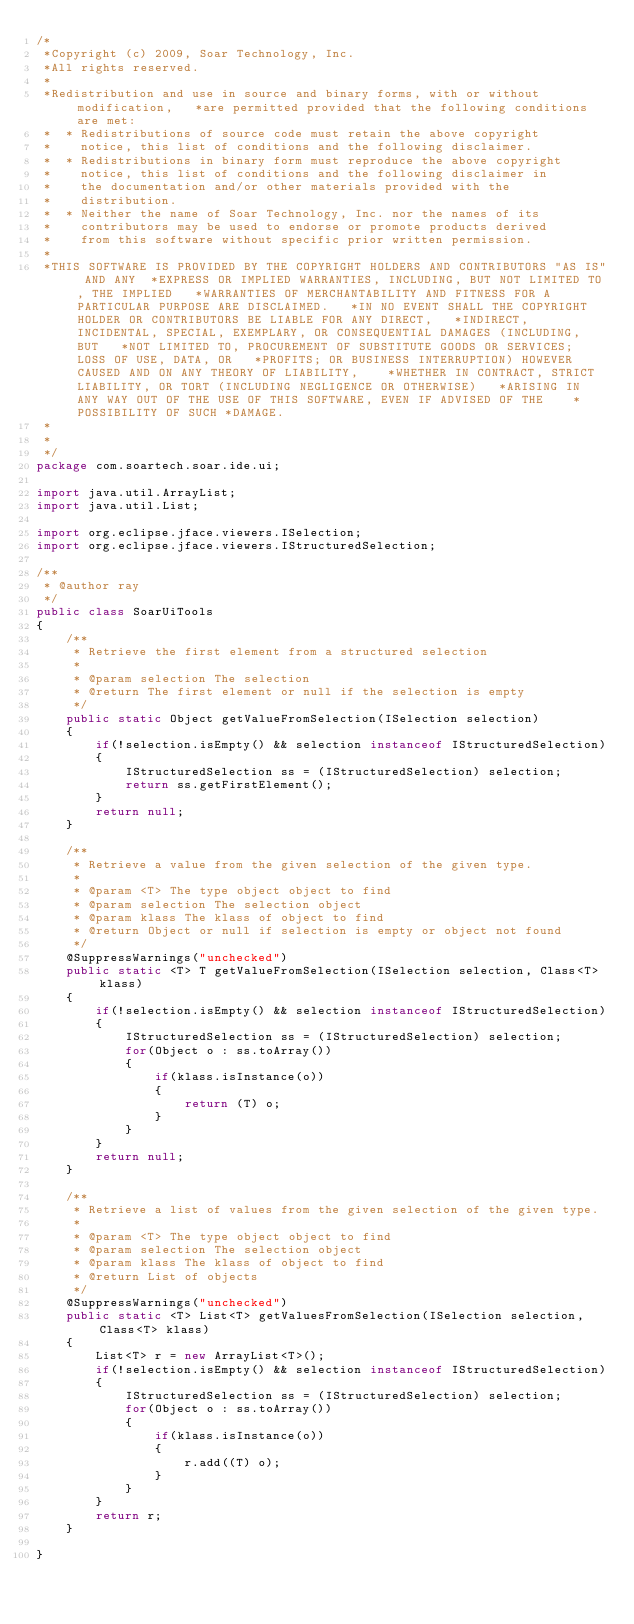<code> <loc_0><loc_0><loc_500><loc_500><_Java_>/*
 *Copyright (c) 2009, Soar Technology, Inc.
 *All rights reserved.
 *
 *Redistribution and use in source and binary forms, with or without modification,   *are permitted provided that the following conditions are met:
 *  * Redistributions of source code must retain the above copyright
 *    notice, this list of conditions and the following disclaimer.
 *  * Redistributions in binary form must reproduce the above copyright
 *    notice, this list of conditions and the following disclaimer in
 *    the documentation and/or other materials provided with the
 *    distribution.
 *  * Neither the name of Soar Technology, Inc. nor the names of its
 *    contributors may be used to endorse or promote products derived
 *    from this software without specific prior written permission.
 *
 *THIS SOFTWARE IS PROVIDED BY THE COPYRIGHT HOLDERS AND CONTRIBUTORS "AS IS" AND ANY  *EXPRESS OR IMPLIED WARRANTIES, INCLUDING, BUT NOT LIMITED TO, THE IMPLIED   *WARRANTIES OF MERCHANTABILITY AND FITNESS FOR A PARTICULAR PURPOSE ARE DISCLAIMED.   *IN NO EVENT SHALL THE COPYRIGHT HOLDER OR CONTRIBUTORS BE LIABLE FOR ANY DIRECT,   *INDIRECT, INCIDENTAL, SPECIAL, EXEMPLARY, OR CONSEQUENTIAL DAMAGES (INCLUDING, BUT   *NOT LIMITED TO, PROCUREMENT OF SUBSTITUTE GOODS OR SERVICES; LOSS OF USE, DATA, OR   *PROFITS; OR BUSINESS INTERRUPTION) HOWEVER CAUSED AND ON ANY THEORY OF LIABILITY,    *WHETHER IN CONTRACT, STRICT LIABILITY, OR TORT (INCLUDING NEGLIGENCE OR OTHERWISE)   *ARISING IN ANY WAY OUT OF THE USE OF THIS SOFTWARE, EVEN IF ADVISED OF THE    *POSSIBILITY OF SUCH *DAMAGE. 
 *
 * 
 */
package com.soartech.soar.ide.ui;

import java.util.ArrayList;
import java.util.List;

import org.eclipse.jface.viewers.ISelection;
import org.eclipse.jface.viewers.IStructuredSelection;

/**
 * @author ray
 */
public class SoarUiTools
{
    /**
     * Retrieve the first element from a structured selection
     * 
     * @param selection The selection
     * @return The first element or null if the selection is empty
     */
    public static Object getValueFromSelection(ISelection selection)
    {
        if(!selection.isEmpty() && selection instanceof IStructuredSelection)
        {
            IStructuredSelection ss = (IStructuredSelection) selection;
            return ss.getFirstElement();
        }
        return null;
    }
    
    /**
     * Retrieve a value from the given selection of the given type.
     * 
     * @param <T> The type object object to find
     * @param selection The selection object
     * @param klass The klass of object to find
     * @return Object or null if selection is empty or object not found
     */
    @SuppressWarnings("unchecked")
    public static <T> T getValueFromSelection(ISelection selection, Class<T> klass)
    {
        if(!selection.isEmpty() && selection instanceof IStructuredSelection)
        {
            IStructuredSelection ss = (IStructuredSelection) selection;
            for(Object o : ss.toArray())
            {
                if(klass.isInstance(o))
                {
                    return (T) o;
                }
            }
        }
        return null;
    }
    
    /**
     * Retrieve a list of values from the given selection of the given type.
     * 
     * @param <T> The type object object to find
     * @param selection The selection object
     * @param klass The klass of object to find
     * @return List of objects
     */
    @SuppressWarnings("unchecked")
    public static <T> List<T> getValuesFromSelection(ISelection selection, Class<T> klass)
    {
        List<T> r = new ArrayList<T>();
        if(!selection.isEmpty() && selection instanceof IStructuredSelection)
        {
            IStructuredSelection ss = (IStructuredSelection) selection;
            for(Object o : ss.toArray())
            {
                if(klass.isInstance(o))
                {
                    r.add((T) o);
                }
            }
        }
        return r;
    }

}
</code> 